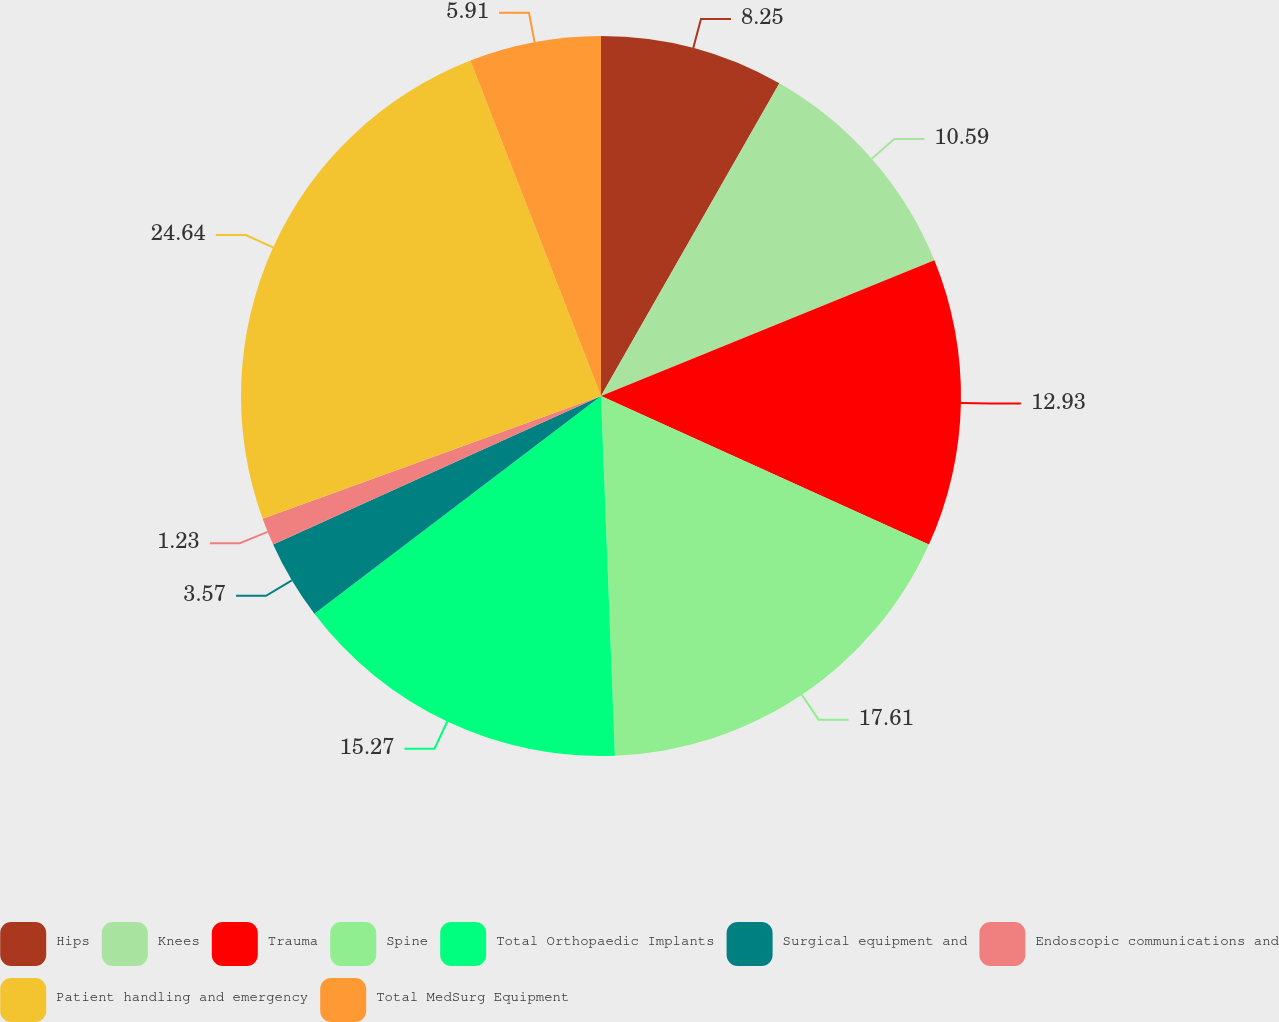<chart> <loc_0><loc_0><loc_500><loc_500><pie_chart><fcel>Hips<fcel>Knees<fcel>Trauma<fcel>Spine<fcel>Total Orthopaedic Implants<fcel>Surgical equipment and<fcel>Endoscopic communications and<fcel>Patient handling and emergency<fcel>Total MedSurg Equipment<nl><fcel>8.25%<fcel>10.59%<fcel>12.93%<fcel>17.61%<fcel>15.27%<fcel>3.57%<fcel>1.23%<fcel>24.63%<fcel>5.91%<nl></chart> 